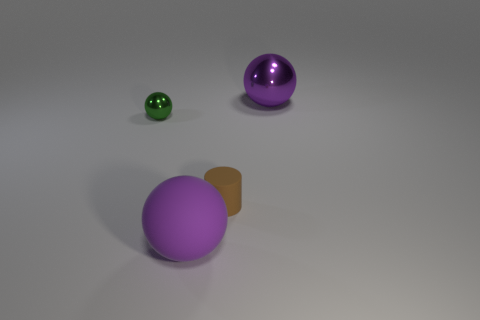Is the shape of the big metal thing the same as the tiny shiny thing?
Provide a short and direct response. Yes. Is there any other thing of the same color as the big matte sphere?
Ensure brevity in your answer.  Yes. There is a large metallic thing that is the same shape as the large purple rubber thing; what is its color?
Provide a succinct answer. Purple. Are there more purple things in front of the green ball than brown rubber cylinders?
Ensure brevity in your answer.  No. There is a object that is behind the tiny shiny sphere; what is its color?
Your answer should be very brief. Purple. Is the size of the cylinder the same as the purple rubber object?
Your response must be concise. No. The purple matte object is what size?
Your answer should be compact. Large. The object that is the same color as the large rubber ball is what shape?
Offer a very short reply. Sphere. Is the number of big gray matte cylinders greater than the number of tiny metallic objects?
Give a very brief answer. No. What color is the big thing in front of the shiny thing to the left of the metal sphere right of the matte cylinder?
Your answer should be very brief. Purple. 